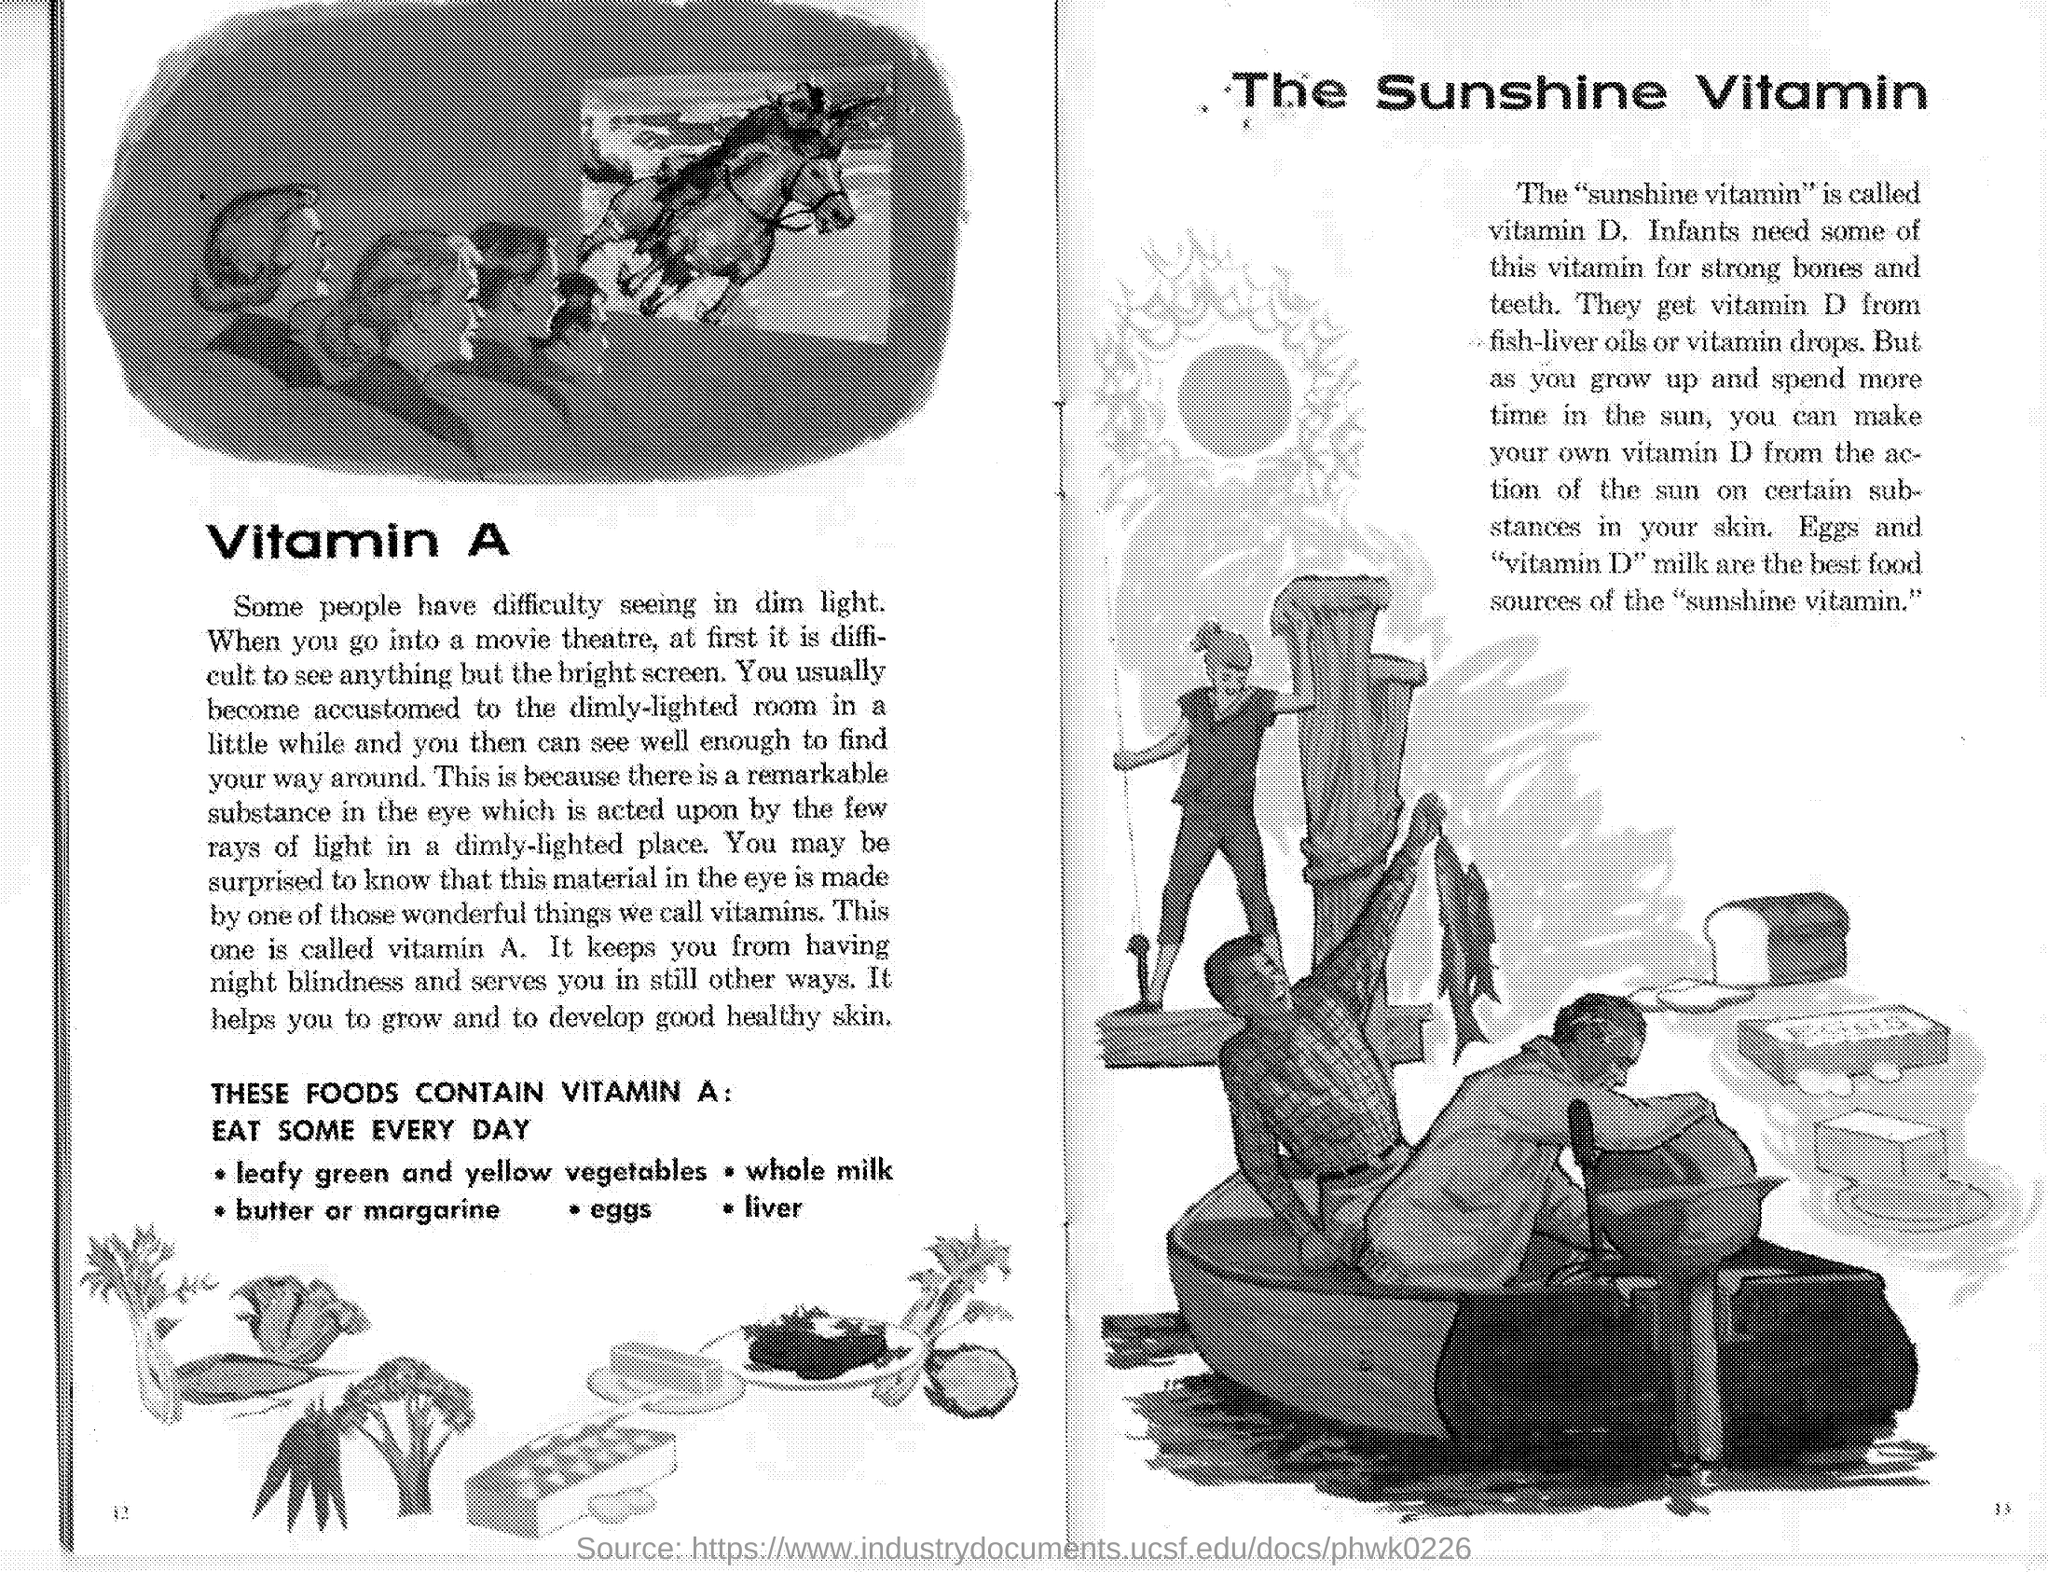Which is the "sunshine vitamin"?
Ensure brevity in your answer.  Vitamin D. 